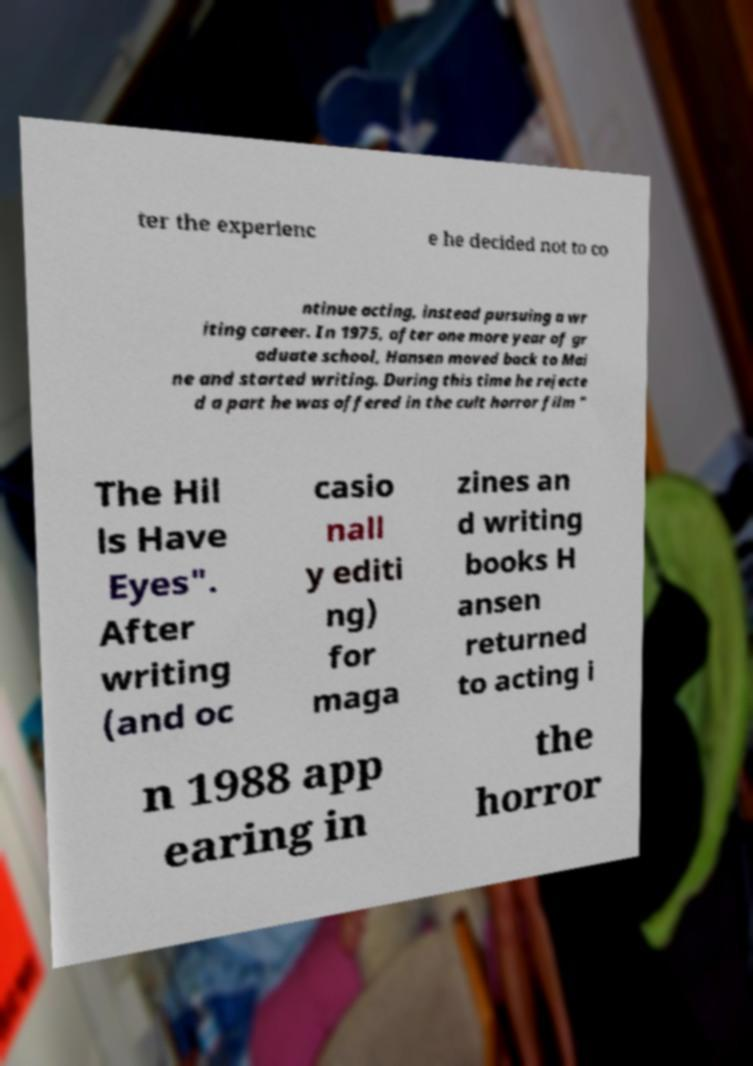Can you accurately transcribe the text from the provided image for me? ter the experienc e he decided not to co ntinue acting, instead pursuing a wr iting career. In 1975, after one more year of gr aduate school, Hansen moved back to Mai ne and started writing. During this time he rejecte d a part he was offered in the cult horror film " The Hil ls Have Eyes". After writing (and oc casio nall y editi ng) for maga zines an d writing books H ansen returned to acting i n 1988 app earing in the horror 